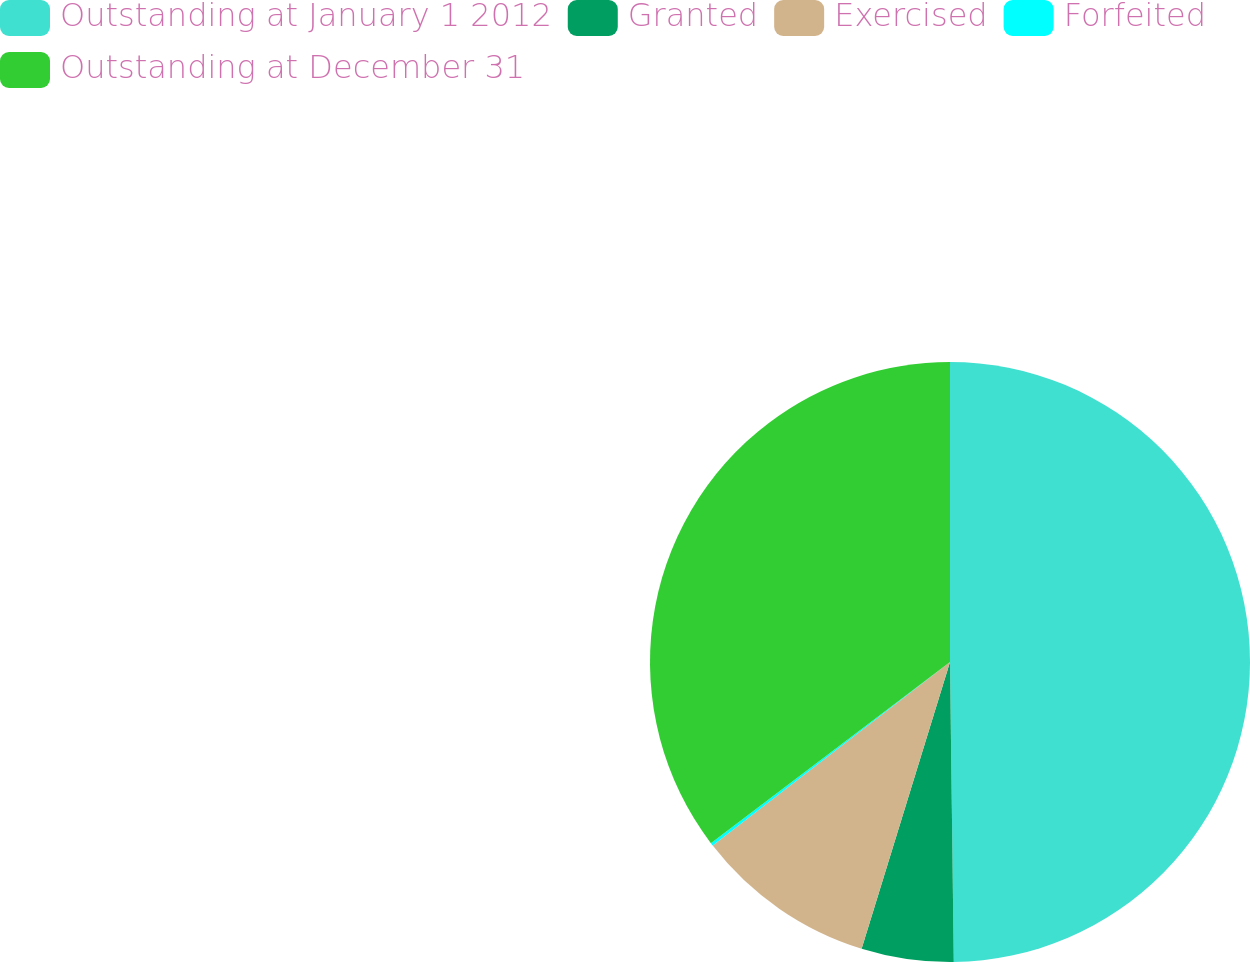Convert chart to OTSL. <chart><loc_0><loc_0><loc_500><loc_500><pie_chart><fcel>Outstanding at January 1 2012<fcel>Granted<fcel>Exercised<fcel>Forfeited<fcel>Outstanding at December 31<nl><fcel>49.8%<fcel>4.96%<fcel>9.76%<fcel>0.16%<fcel>35.32%<nl></chart> 